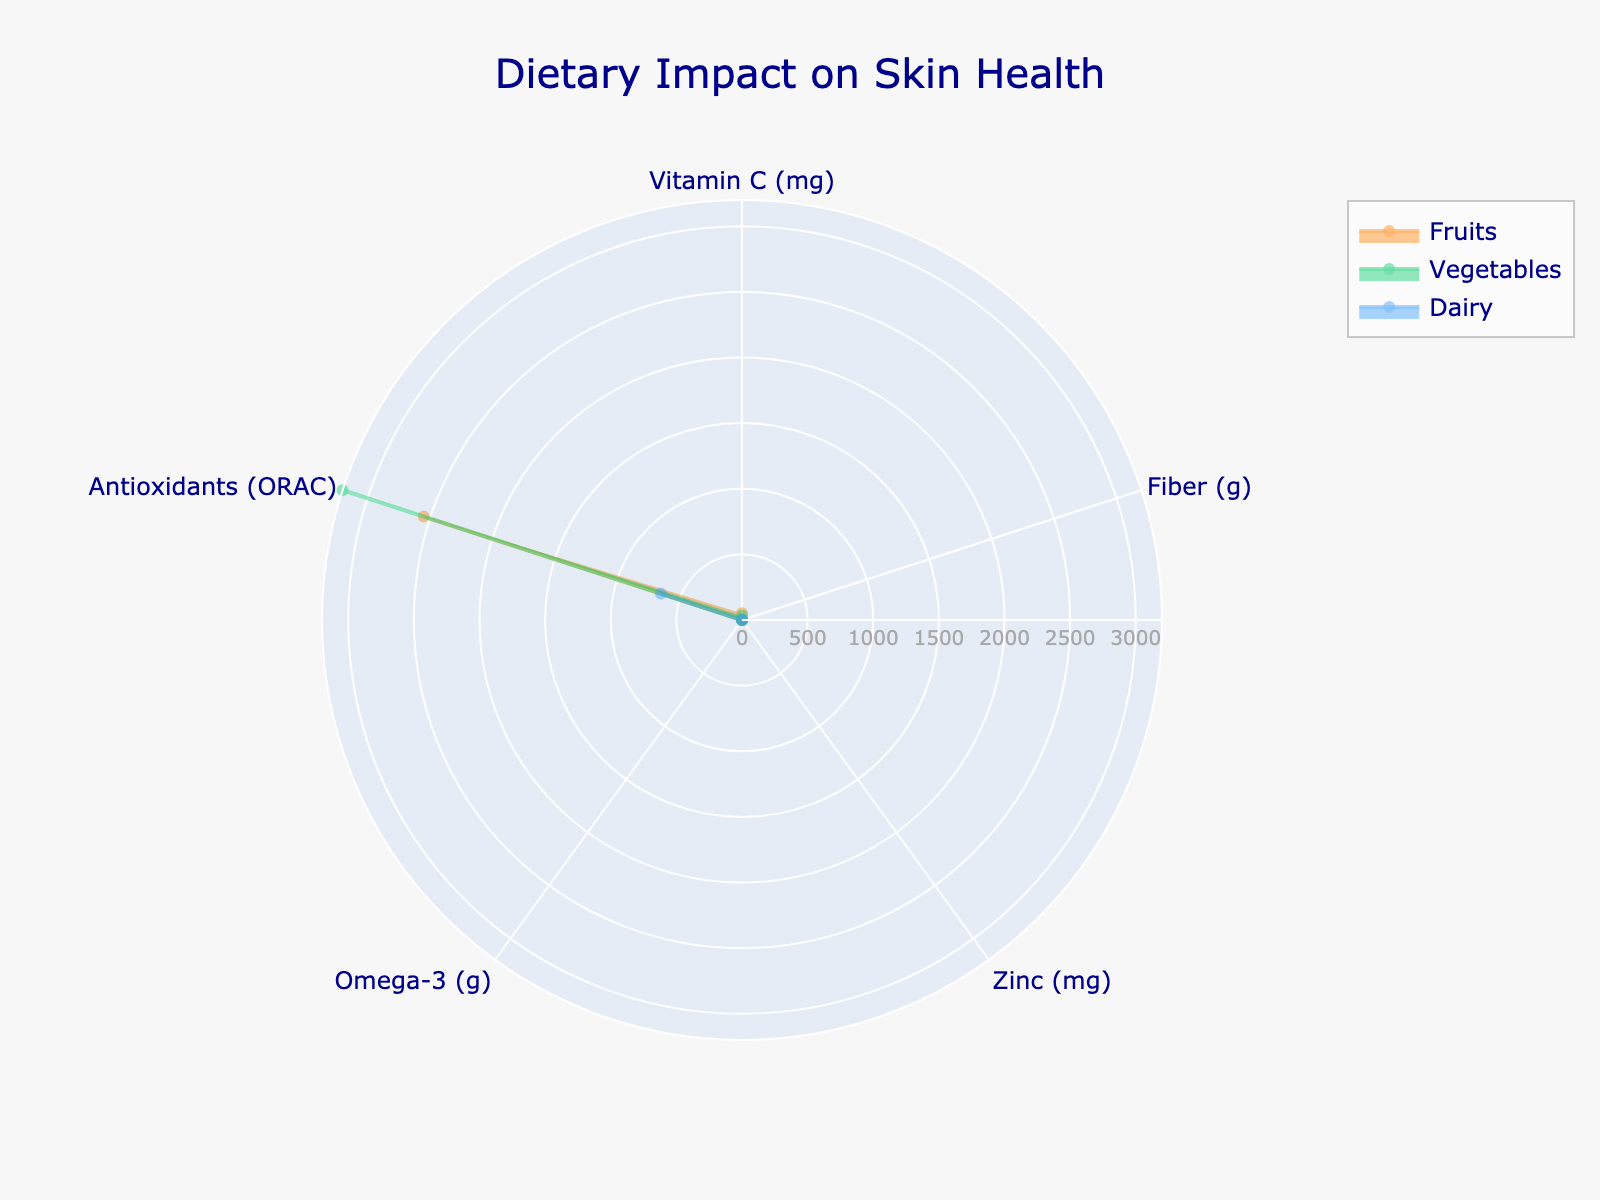What is the title of the chart? The title of the chart is typically displayed at the top of the figure. From the customization in the code, the title is 'Dietary Impact on Skin Health'.
Answer: Dietary Impact on Skin Health What is the food group with the highest value for Antioxidants? Examine the Antioxidants data for each food group. Vegetables have the highest value of 3200.
Answer: Vegetables Which food group contains the highest amount of Fiber? Compare the Fiber values across all food groups. Vegetables have the highest Fiber amount of 4.1 grams.
Answer: Vegetables How do the Vitamin C values compare between Fruits and Vegetables? Fruits contain 52 mg of Vitamin C while Vegetables contain 33 mg. Fruits have more Vitamin C than Vegetables.
Answer: Fruits have higher Vitamin C than Vegetables How many categories are compared in the radar chart? Count the number of distinct categories or dimensions along which the food groups are measured. There are five categories: Vitamin C, Fiber, Zinc, Omega-3, and Antioxidants.
Answer: 5 Which food group has the lowest Omega-3 content? Compare the Omega-3 values across all food groups. Both Fruits and Dairy have very low values of 0.02 and 0, respectively, but Dairy has the lowest (0).
Answer: Dairy What is the difference in Zinc content between Vegetables and Dairy? The Zinc content for Vegetables is 0.3 mg and for Dairy, it is 1.1 mg. The difference is 1.1 - 0.3 = 0.8 mg.
Answer: 0.8 mg Which food group has the most balanced distribution across all categories? "Most balanced" implies a relatively even spread across all measured categories. Compare the spreads visually; Fruits and Vegetables have more balanced distributions, but Vegetables cover more categories evenly.
Answer: Vegetables Which food group provides the highest value for a single category, and what is that value? Look for the maximum single value across all categories and food groups. Vegetables have the highest value for Antioxidants at 3200.
Answer: Vegetables, 3200 What is the sum of the Vitamin C values from all food groups? Add the Vitamin C values: 52 (Fruits) + 33 (Vegetables) + 0.5 (Dairy) = 85.5 mg.
Answer: 85.5 mg 